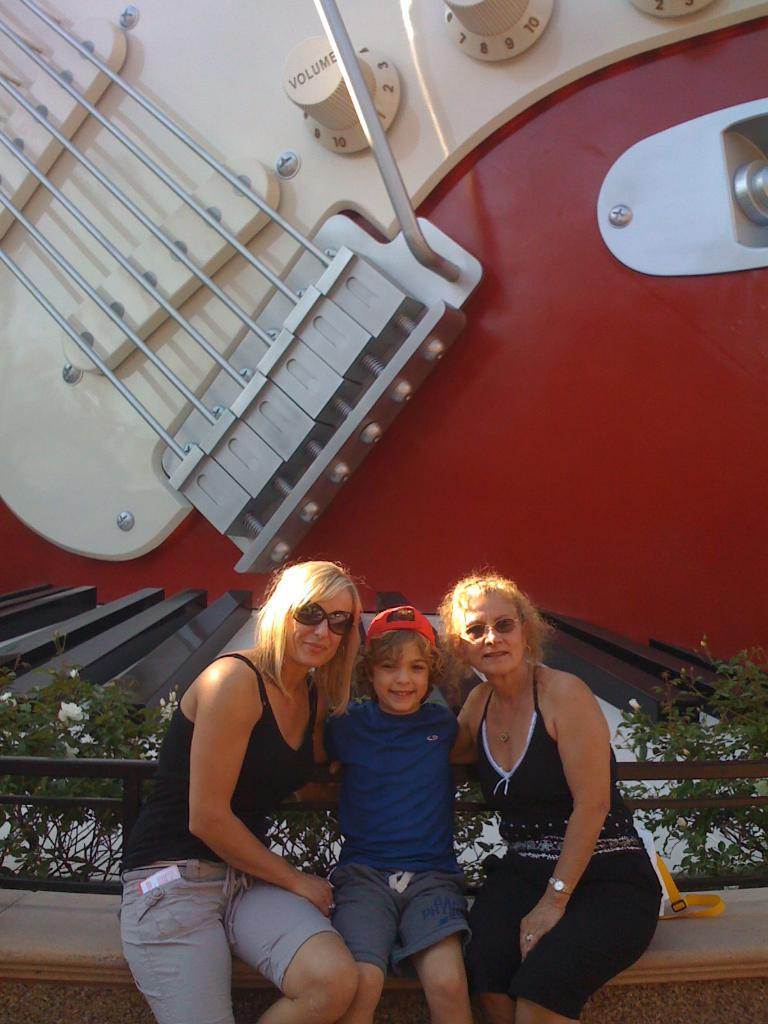What are the people in the image doing? The people in the image are sitting. What can be seen in the background of the image? There is a music instrument with strings and volume buttons visible in the background of the image. What type of boot is the manager wearing in the image? There is no manager or boot present in the image. What does the mom say about the music instrument in the image? There is no mom or dialogue present in the image. 